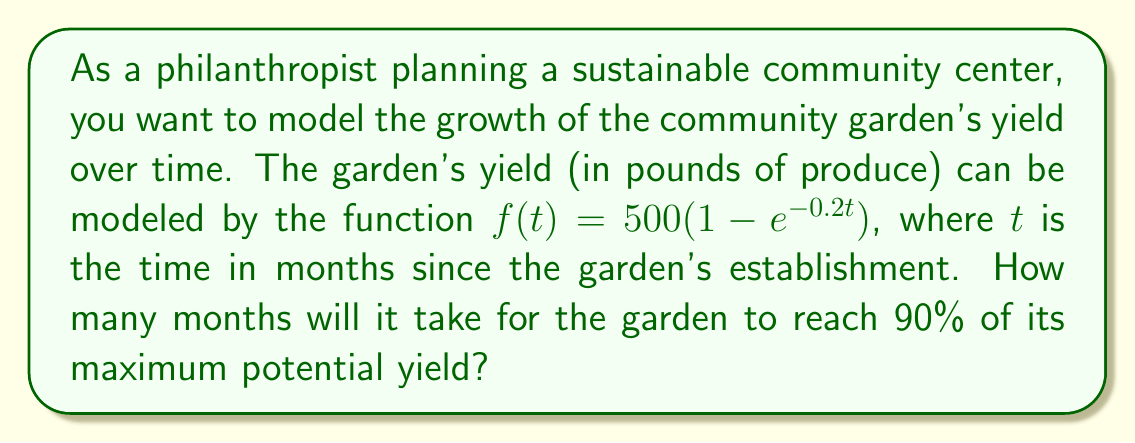Could you help me with this problem? Let's approach this step-by-step:

1) First, we need to understand what the function represents:
   $f(t) = 500(1 - e^{-0.2t})$
   Here, 500 represents the maximum potential yield in pounds.

2) We want to find when the yield reaches 90% of the maximum. This means:
   $f(t) = 0.90 \times 500 = 450$

3) Now, we can set up the equation:
   $450 = 500(1 - e^{-0.2t})$

4) Divide both sides by 500:
   $0.90 = 1 - e^{-0.2t}$

5) Subtract both sides from 1:
   $0.10 = e^{-0.2t}$

6) Take the natural log of both sides:
   $\ln(0.10) = -0.2t$

7) Solve for t:
   $t = \frac{\ln(0.10)}{-0.2} = \frac{-2.30259}{-0.2} \approx 11.51$

8) Since we're dealing with months, we round up to the nearest whole number.
Answer: 12 months 